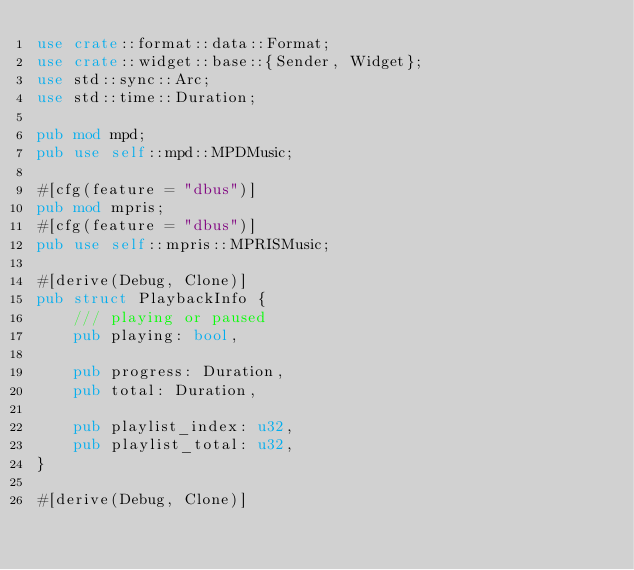Convert code to text. <code><loc_0><loc_0><loc_500><loc_500><_Rust_>use crate::format::data::Format;
use crate::widget::base::{Sender, Widget};
use std::sync::Arc;
use std::time::Duration;

pub mod mpd;
pub use self::mpd::MPDMusic;

#[cfg(feature = "dbus")]
pub mod mpris;
#[cfg(feature = "dbus")]
pub use self::mpris::MPRISMusic;

#[derive(Debug, Clone)]
pub struct PlaybackInfo {
    /// playing or paused
    pub playing: bool,

    pub progress: Duration,
    pub total: Duration,

    pub playlist_index: u32,
    pub playlist_total: u32,
}

#[derive(Debug, Clone)]</code> 